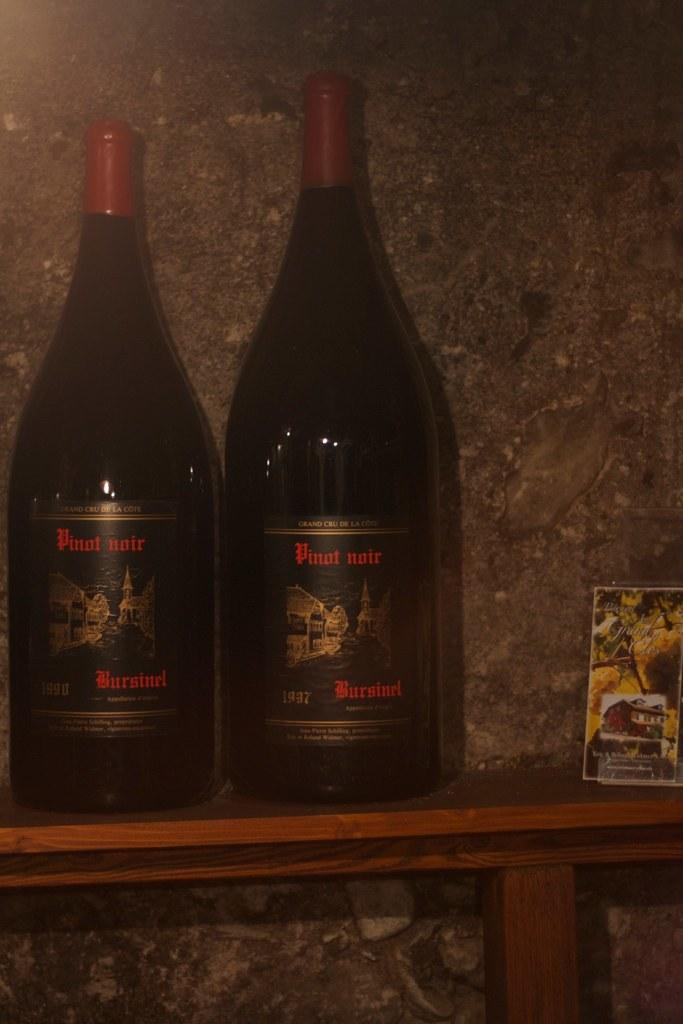<image>
Create a compact narrative representing the image presented. Two bottles labeled Pinot noir sit on a shelf next to a picture. 